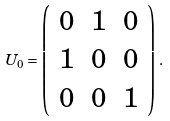Convert formula to latex. <formula><loc_0><loc_0><loc_500><loc_500>U _ { 0 } = \left ( \begin{array} { c c c } 0 & 1 & 0 \\ 1 & 0 & 0 \\ 0 & 0 & 1 \end{array} \right ) \, .</formula> 